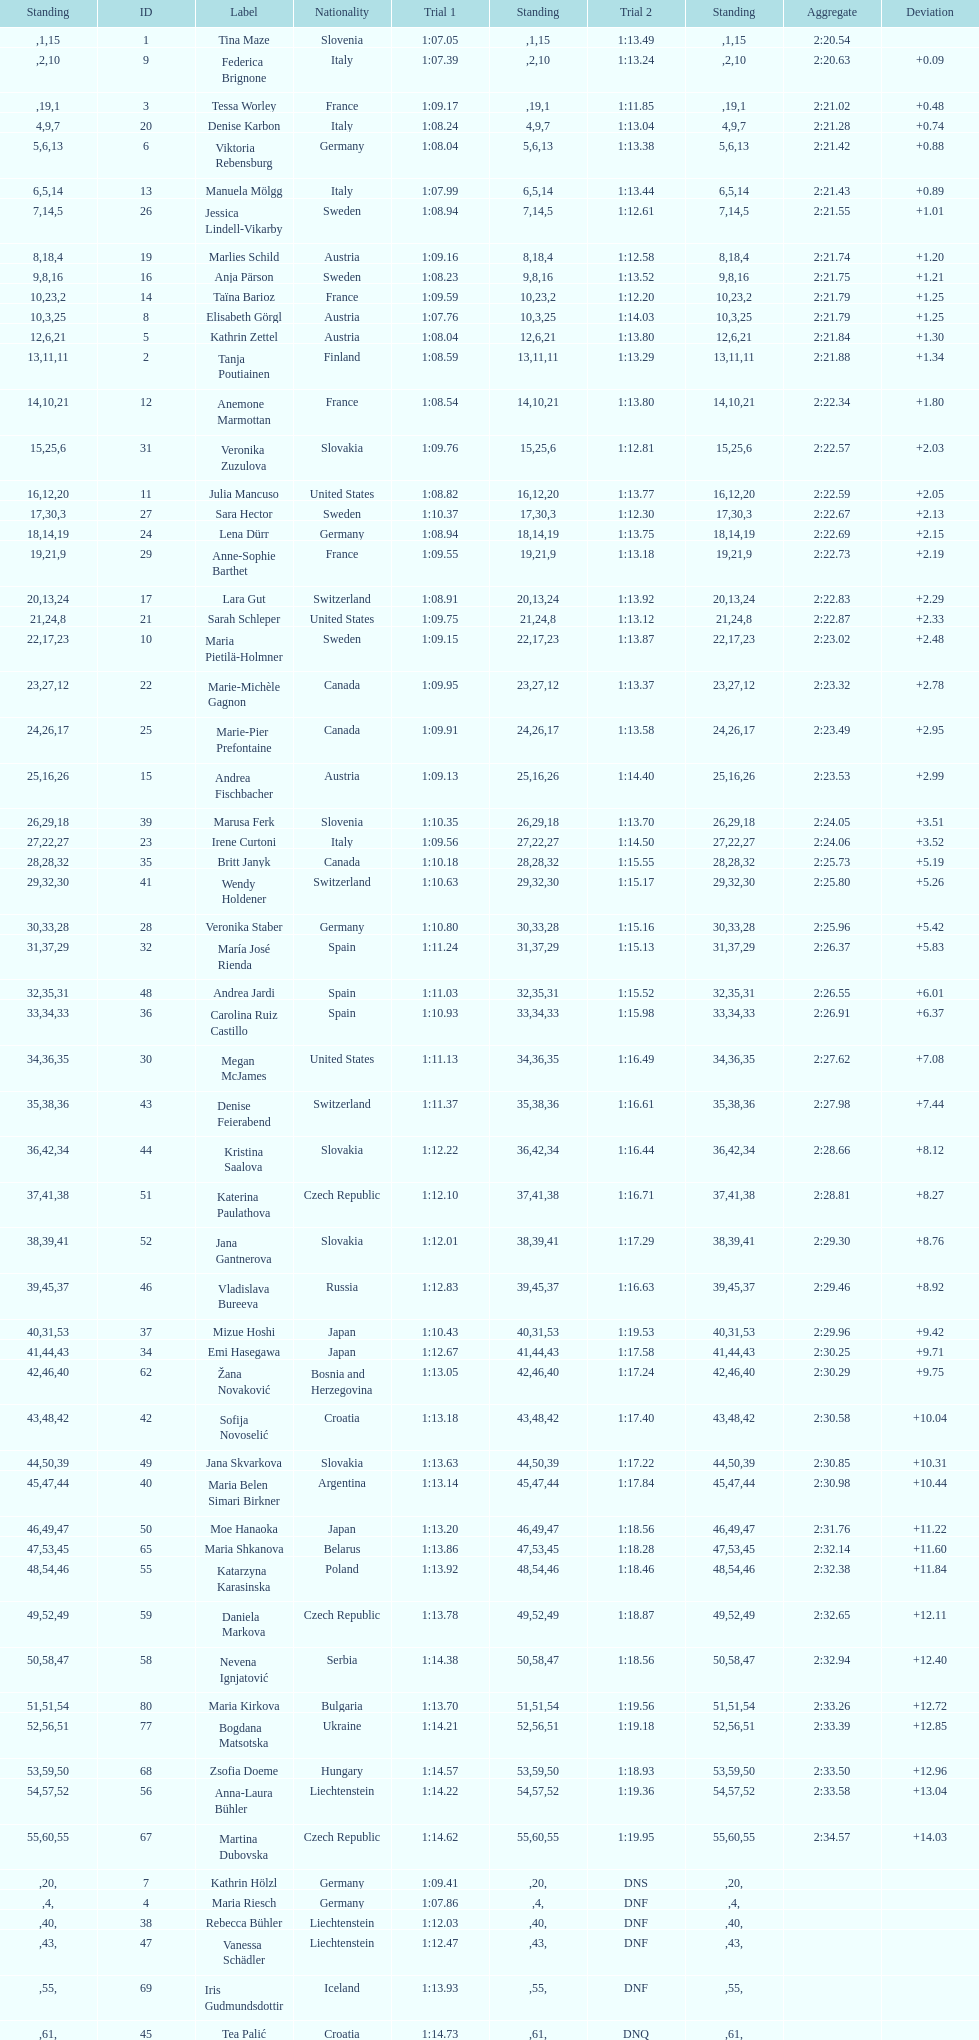Who was the last competitor to actually finish both runs? Martina Dubovska. 